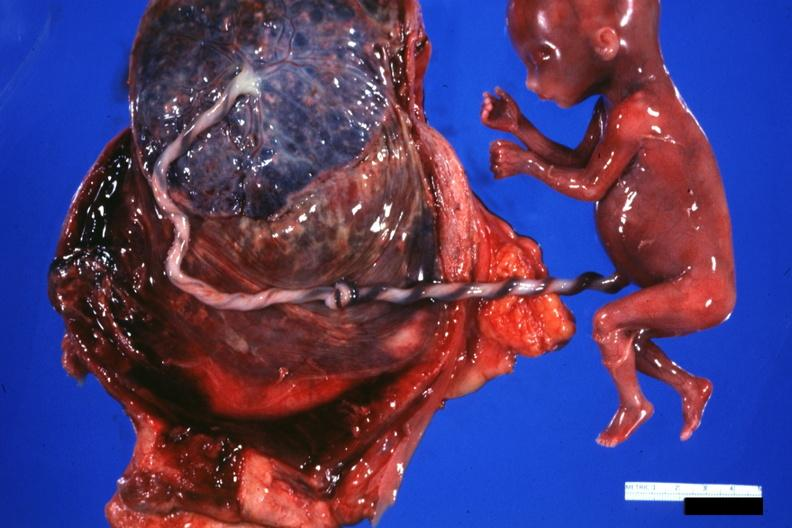does this image show fetus cord with knot and placenta?
Answer the question using a single word or phrase. Yes 